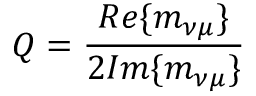<formula> <loc_0><loc_0><loc_500><loc_500>Q = \frac { R e \{ m _ { \nu \mu } \} } { 2 I m \{ m _ { \nu \mu } \} }</formula> 